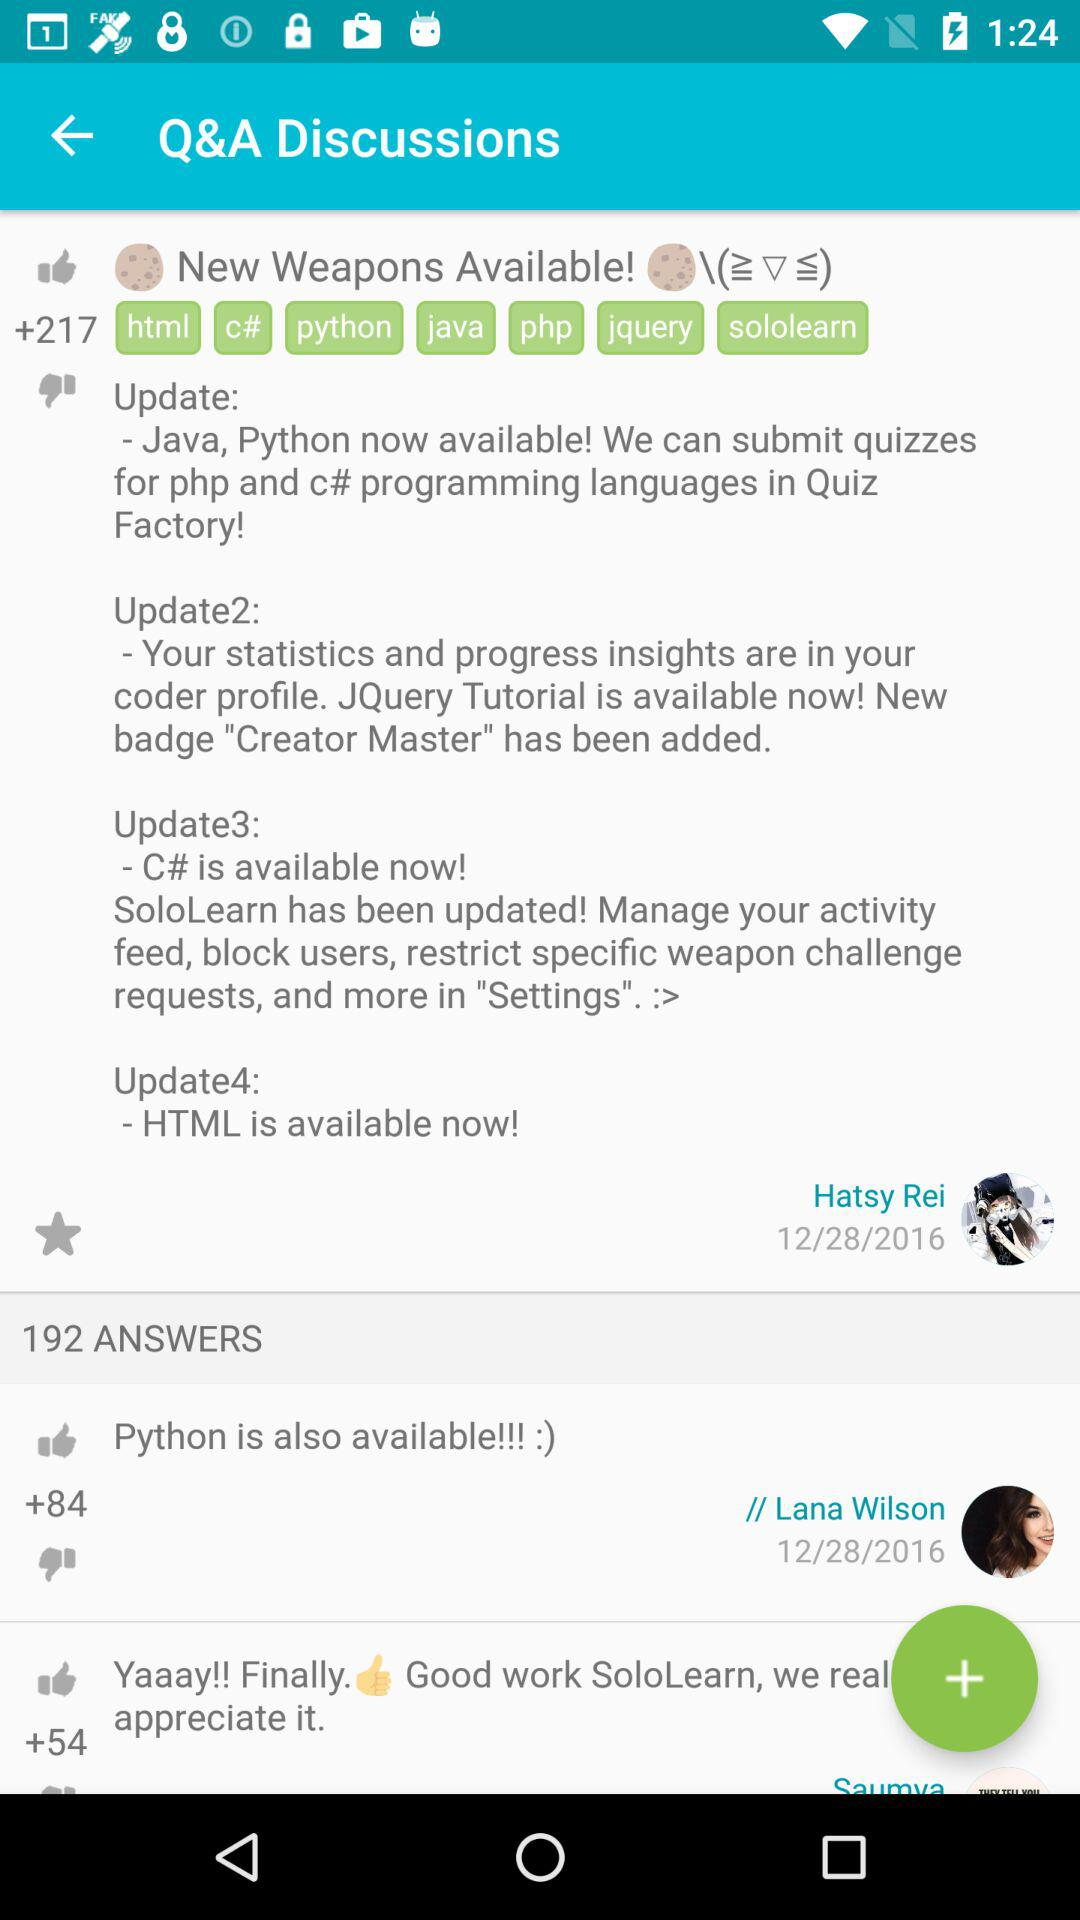How many thumbs up are there for Python?
Answer the question using a single word or phrase. 84 